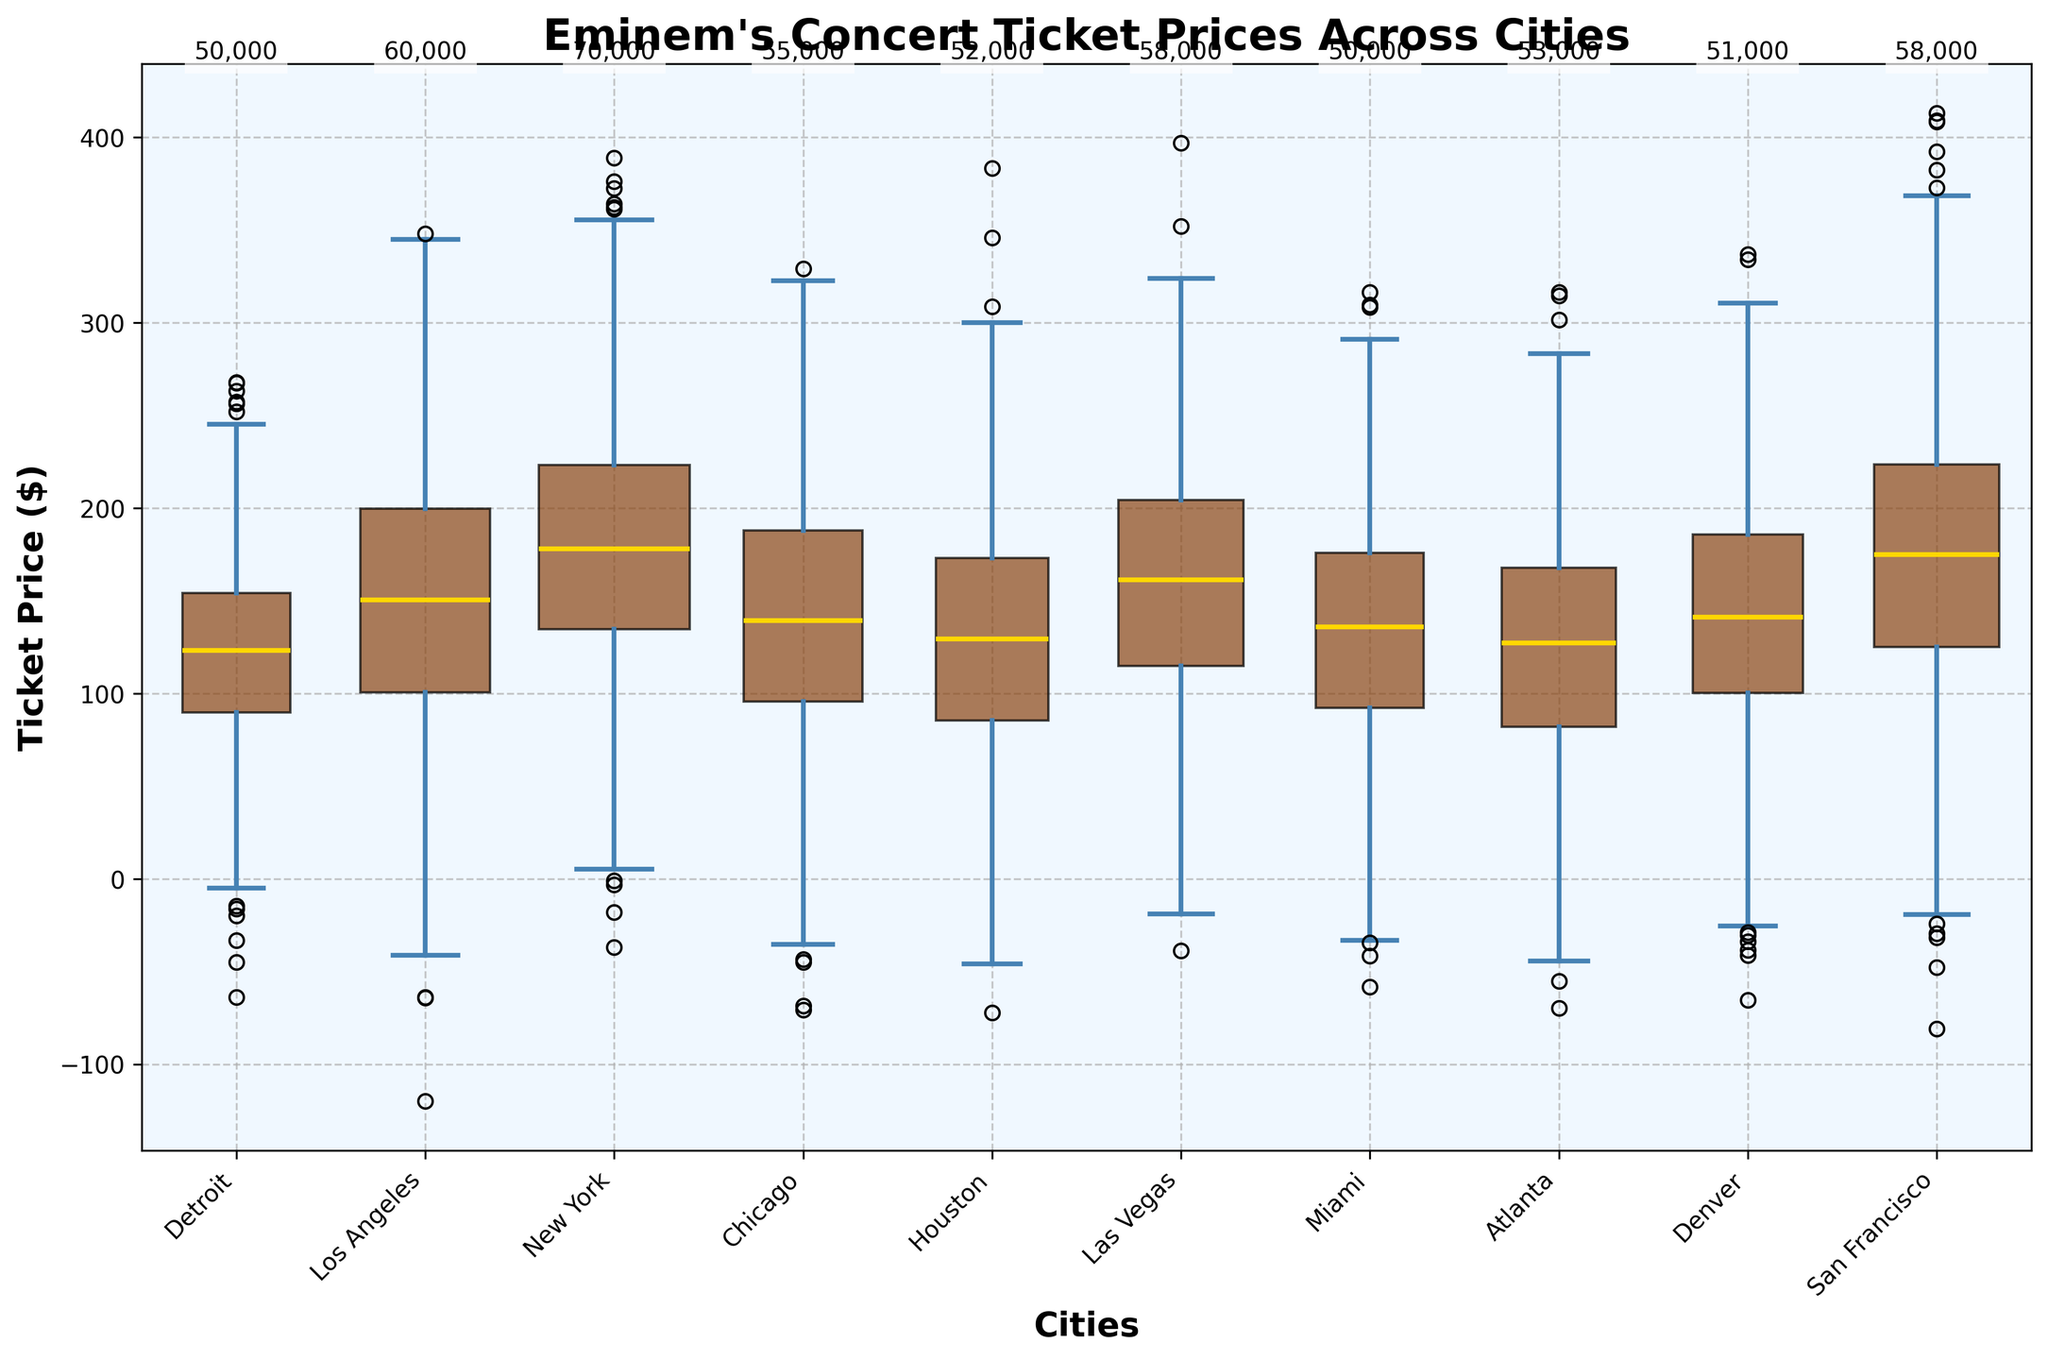What's the median ticket price for Eminem's concert in New York? The box plot shows the median ticket prices for each city. For New York, the median value is marked with a gold line in the New York box, which corresponds to 180 dollars.
Answer: 180 dollars What city has the highest upper quartile ticket price for Eminem's concerts? The upper quartile price for each city is represented by the top boundary of the colored box. New York and San Francisco both have the highest upper quartile price set at 220 dollars.
Answer: New York and San Francisco Which city shows the widest range between the lower quartile and the upper quartile ticket prices? The distance between the lower quartile and upper quartile is the height of the colored box. New York has the widest range, represented by the largest difference between the upper and lower quartiles, which is 90 dollars (220 - 130).
Answer: New York Compare the median ticket prices of Detroit and Miami. What can you conclude? The gold line in the Detroit box plot shows a median ticket price of 120 dollars, and the gold line in the Miami box plot shows a median ticket price of 135 dollars. Comparing both, Miami has a higher median ticket price than Detroit by 15 dollars.
Answer: Miami has a higher median by 15 dollars How does the attendance affect the width of the boxes in the box plot? The width of the boxes is proportional to the attendance values for each city. Larger attendances mean wider boxes. For example, New York with the highest attendance of 70,000 has a box significantly wider compared to cities like Miami, which has an attendance of 50,000.
Answer: Higher attendance, wider boxes What is the interquartile range (IQR) for ticket prices in Chicago? The IQR is calculated as the difference between the upper and lower quartiles. For Chicago, the upper quartile is 180 dollars and the lower quartile is 90 dollars. Thus, IQR = 180 - 90 = 90 dollars.
Answer: 90 dollars Which city has the longest whiskers relative to its box height, and what does this suggest? Whiskers are the lines extending from the boxes and show the variability outside the upper and lower quartiles. Las Vegas has longer whiskers relative to its box height, suggesting a greater variability in ticket prices.
Answer: Las Vegas If you are looking for the city with the most consistent ticket pricing, which one would you choose and why? Consistent pricing is indicated by a smaller range within the box and shorter whiskers. Detroit shows a relatively small range and shorter whiskers compared to other cities, suggesting more consistent ticket prices.
Answer: Detroit Compare the variability of ticket prices between Denver and Las Vegas. Las Vegas has larger interquartile range (90 dollars from 120 to 210) and longer whiskers compared to Denver's interquartile range (90 dollars from 100 to 190), indicating more variability in Las Vegas ticket prices.
Answer: Las Vegas has more variability 